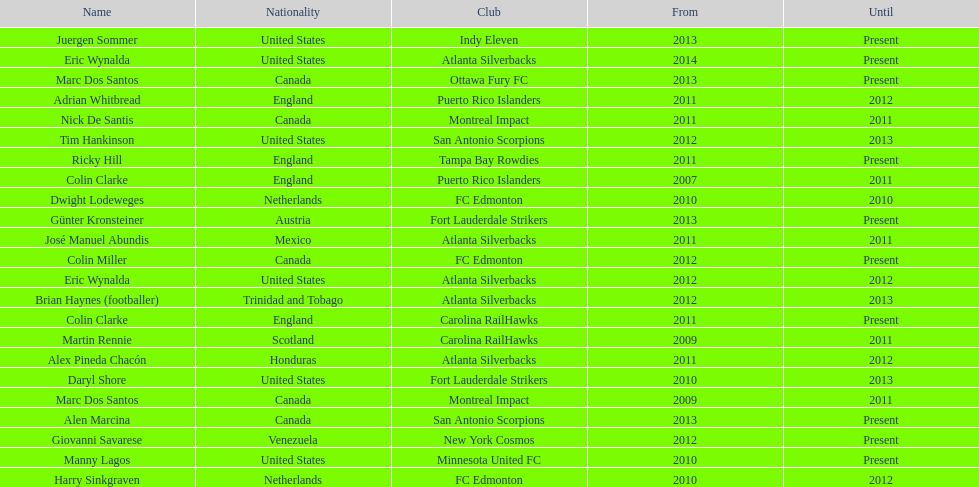Who is the last to coach the san antonio scorpions? Alen Marcina. 